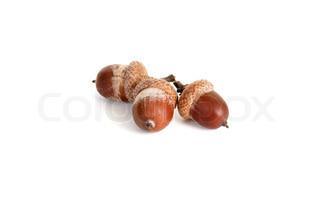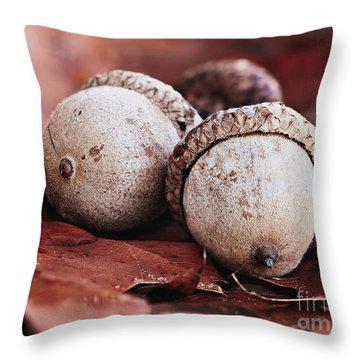The first image is the image on the left, the second image is the image on the right. Given the left and right images, does the statement "The left image contains exactly three brown acorns with their caps on." hold true? Answer yes or no. Yes. 